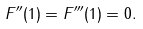Convert formula to latex. <formula><loc_0><loc_0><loc_500><loc_500>F ^ { \prime \prime } ( 1 ) = F ^ { \prime \prime \prime } ( 1 ) = 0 .</formula> 